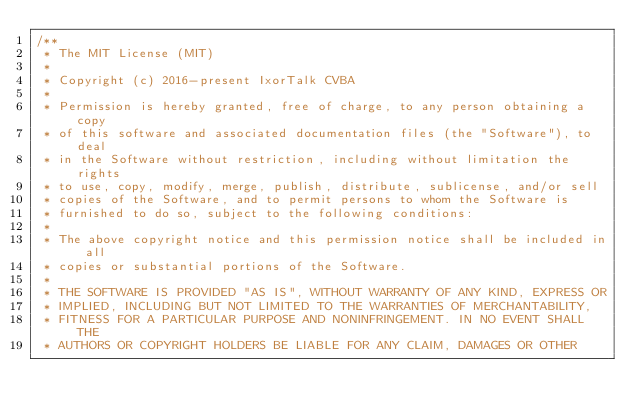Convert code to text. <code><loc_0><loc_0><loc_500><loc_500><_Java_>/**
 * The MIT License (MIT)
 *
 * Copyright (c) 2016-present IxorTalk CVBA
 *
 * Permission is hereby granted, free of charge, to any person obtaining a copy
 * of this software and associated documentation files (the "Software"), to deal
 * in the Software without restriction, including without limitation the rights
 * to use, copy, modify, merge, publish, distribute, sublicense, and/or sell
 * copies of the Software, and to permit persons to whom the Software is
 * furnished to do so, subject to the following conditions:
 *
 * The above copyright notice and this permission notice shall be included in all
 * copies or substantial portions of the Software.
 *
 * THE SOFTWARE IS PROVIDED "AS IS", WITHOUT WARRANTY OF ANY KIND, EXPRESS OR
 * IMPLIED, INCLUDING BUT NOT LIMITED TO THE WARRANTIES OF MERCHANTABILITY,
 * FITNESS FOR A PARTICULAR PURPOSE AND NONINFRINGEMENT. IN NO EVENT SHALL THE
 * AUTHORS OR COPYRIGHT HOLDERS BE LIABLE FOR ANY CLAIM, DAMAGES OR OTHER</code> 